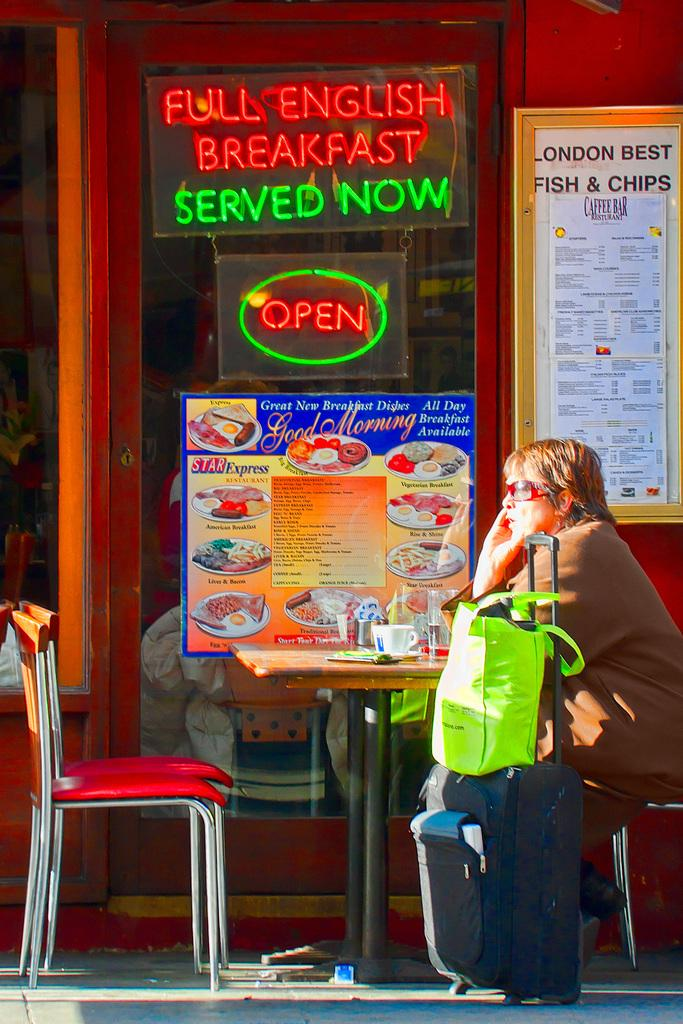What is the person in the image doing? The person is sitting on a chair in the image. What is located near the person? The person has luggage beside them. Where is the person sitting? The person is sitting at a table. What can be seen on the glass door in the image? There is a poster on the glass door. What type of notebook is the person using in the image? There is no notebook present in the image. What class is the person attending in the image? There is no indication of a class or educational setting in the image. 